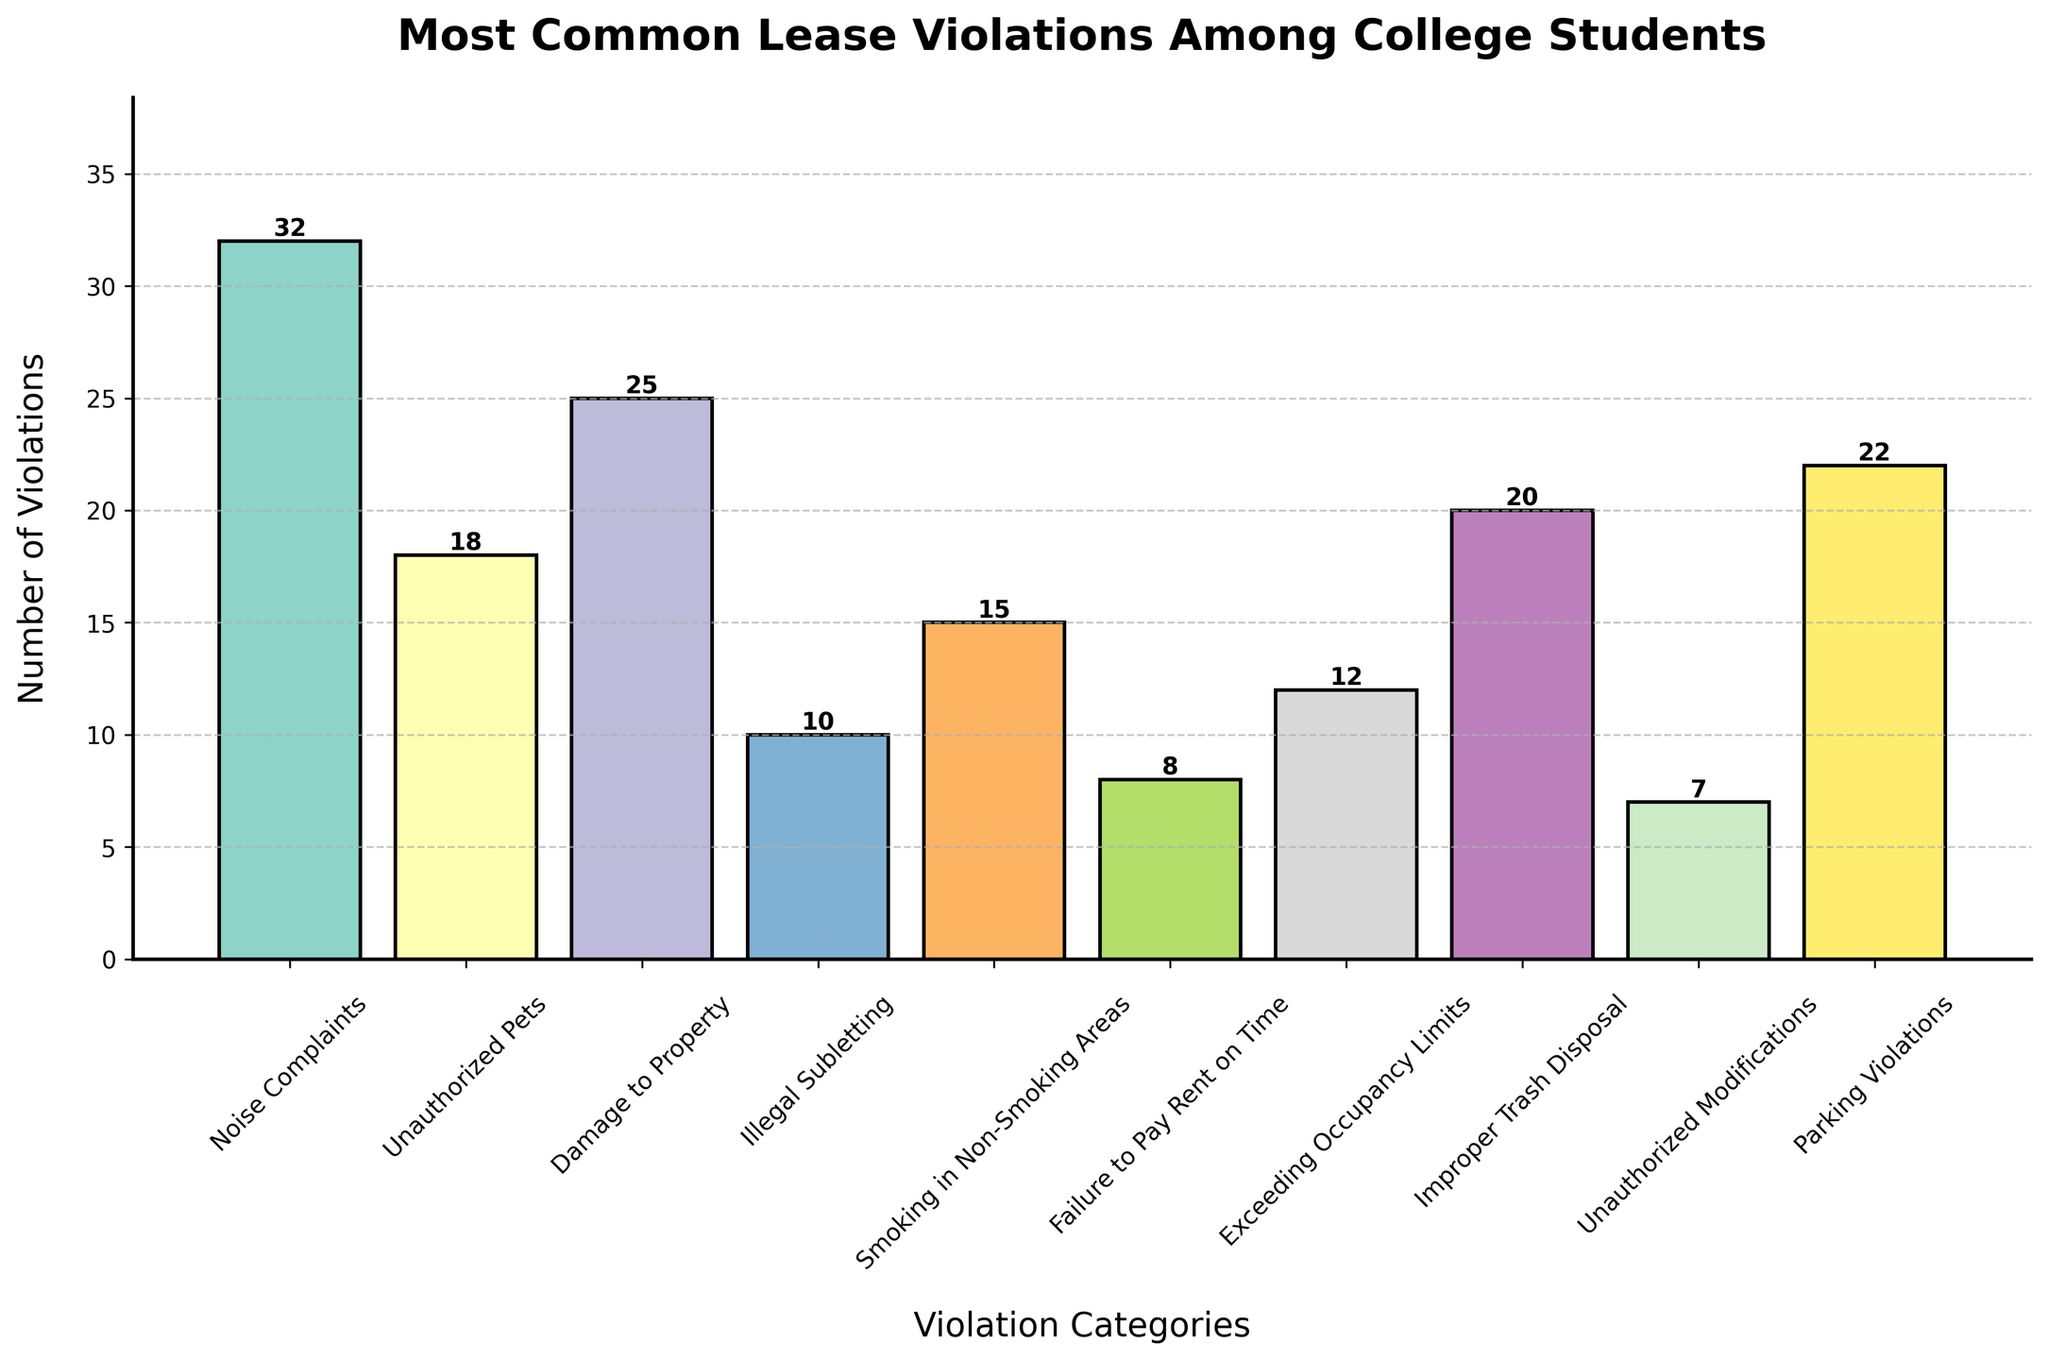What's the most common lease violation among college students? Identify the highest bar in the plot, which represents the category with the most violations. In this case, the highest bar is for 'Noise Complaints' with 32 violations.
Answer: Noise Complaints Which lease violation has the fewest occurrences? Identify the shortest bar in the plot. The shortest bar represents 'Unauthorized Modifications' with 7 violations.
Answer: Unauthorized Modifications How many more 'Noise Complaints' are there compared to 'Failure to Pay Rent on Time'? Look at the heights of the bars for 'Noise Complaints' and 'Failure to Pay Rent on Time'. 'Noise Complaints' has 32 violations and 'Failure to Pay Rent on Time' has 8 violations, so the difference is 32 - 8.
Answer: 24 What is the combined total of 'Damage to Property' and 'Parking Violations'? Add the heights of the bars for 'Damage to Property' (25) and 'Parking Violations' (22).
Answer: 47 Which categories have violation counts greater than 20? Identify the bars whose heights are above the 20 mark. The categories are 'Noise Complaints' (32), 'Damage to Property' (25), and 'Parking Violations' (22).
Answer: Noise Complaints, Damage to Property, Parking Violations What is the average number of violations for the categories listed? Sum all the violation numbers and divide by the number of categories. The sum is 169 and there are 10 categories, so the average is 169 / 10.
Answer: 16.9 Is 'Improper Trash Disposal' more frequent than 'Illegal Subletting'? Compare the heights of the bars for 'Improper Trash Disposal' (20) and 'Illegal Subletting' (10). 'Improper Trash Disposal' has more violations.
Answer: Yes How many violations fall in the middle range between the lowest ('Unauthorized Modifications') and highest ('Noise Complaints') counts? The categories excluding 'Unauthorized Modifications' (7) and 'Noise Complaints' (32) are: 'Unauthorized Pets' (18), 'Damage to Property' (25), 'Illegal Subletting' (10), 'Smoking in Non-Smoking Areas' (15), 'Failure to Pay Rent on Time' (8), 'Exceeding Occupancy Limits' (12), 'Improper Trash Disposal' (20), 'Parking Violations' (22). Count these categories.
Answer: 8 What is the total number of violations for all categories? Add the violation counts for all categories. The sum is 32 + 18 + 25 + 10 + 15 + 8 + 12 + 20 + 7 + 22.
Answer: 169 By how much does 'Unauthorized Pets' exceed 'Illegal Subletting' in violation counts? Subtract the number of 'Illegal Subletting' violations (10) from 'Unauthorized Pets' violations (18).
Answer: 8 